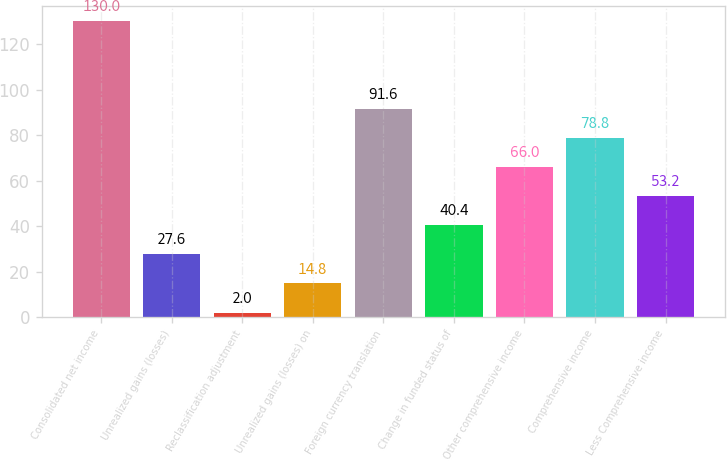<chart> <loc_0><loc_0><loc_500><loc_500><bar_chart><fcel>Consolidated net income<fcel>Unrealized gains (losses)<fcel>Reclassification adjustment<fcel>Unrealized gains (losses) on<fcel>Foreign currency translation<fcel>Change in funded status of<fcel>Other comprehensive income<fcel>Comprehensive income<fcel>Less Comprehensive income<nl><fcel>130<fcel>27.6<fcel>2<fcel>14.8<fcel>91.6<fcel>40.4<fcel>66<fcel>78.8<fcel>53.2<nl></chart> 